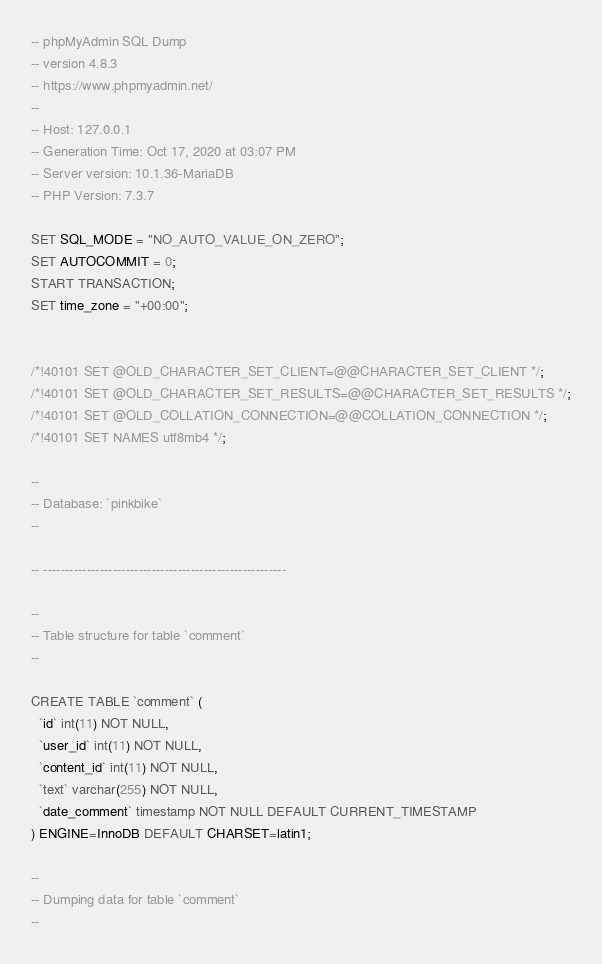<code> <loc_0><loc_0><loc_500><loc_500><_SQL_>-- phpMyAdmin SQL Dump
-- version 4.8.3
-- https://www.phpmyadmin.net/
--
-- Host: 127.0.0.1
-- Generation Time: Oct 17, 2020 at 03:07 PM
-- Server version: 10.1.36-MariaDB
-- PHP Version: 7.3.7

SET SQL_MODE = "NO_AUTO_VALUE_ON_ZERO";
SET AUTOCOMMIT = 0;
START TRANSACTION;
SET time_zone = "+00:00";


/*!40101 SET @OLD_CHARACTER_SET_CLIENT=@@CHARACTER_SET_CLIENT */;
/*!40101 SET @OLD_CHARACTER_SET_RESULTS=@@CHARACTER_SET_RESULTS */;
/*!40101 SET @OLD_COLLATION_CONNECTION=@@COLLATION_CONNECTION */;
/*!40101 SET NAMES utf8mb4 */;

--
-- Database: `pinkbike`
--

-- --------------------------------------------------------

--
-- Table structure for table `comment`
--

CREATE TABLE `comment` (
  `id` int(11) NOT NULL,
  `user_id` int(11) NOT NULL,
  `content_id` int(11) NOT NULL,
  `text` varchar(255) NOT NULL,
  `date_comment` timestamp NOT NULL DEFAULT CURRENT_TIMESTAMP
) ENGINE=InnoDB DEFAULT CHARSET=latin1;

--
-- Dumping data for table `comment`
--
</code> 